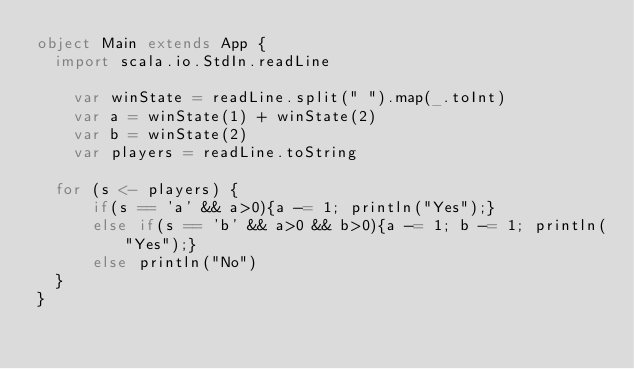Convert code to text. <code><loc_0><loc_0><loc_500><loc_500><_Scala_>object Main extends App {
  import scala.io.StdIn.readLine

  	var winState = readLine.split(" ").map(_.toInt)
    var a = winState(1) + winState(2)
  	var b = winState(2)
    var players = readLine.toString

  for (s <- players) {
      if(s == 'a' && a>0){a -= 1; println("Yes");}
      else if(s == 'b' && a>0 && b>0){a -= 1; b -= 1; println("Yes");}
      else println("No")
  }
}
</code> 